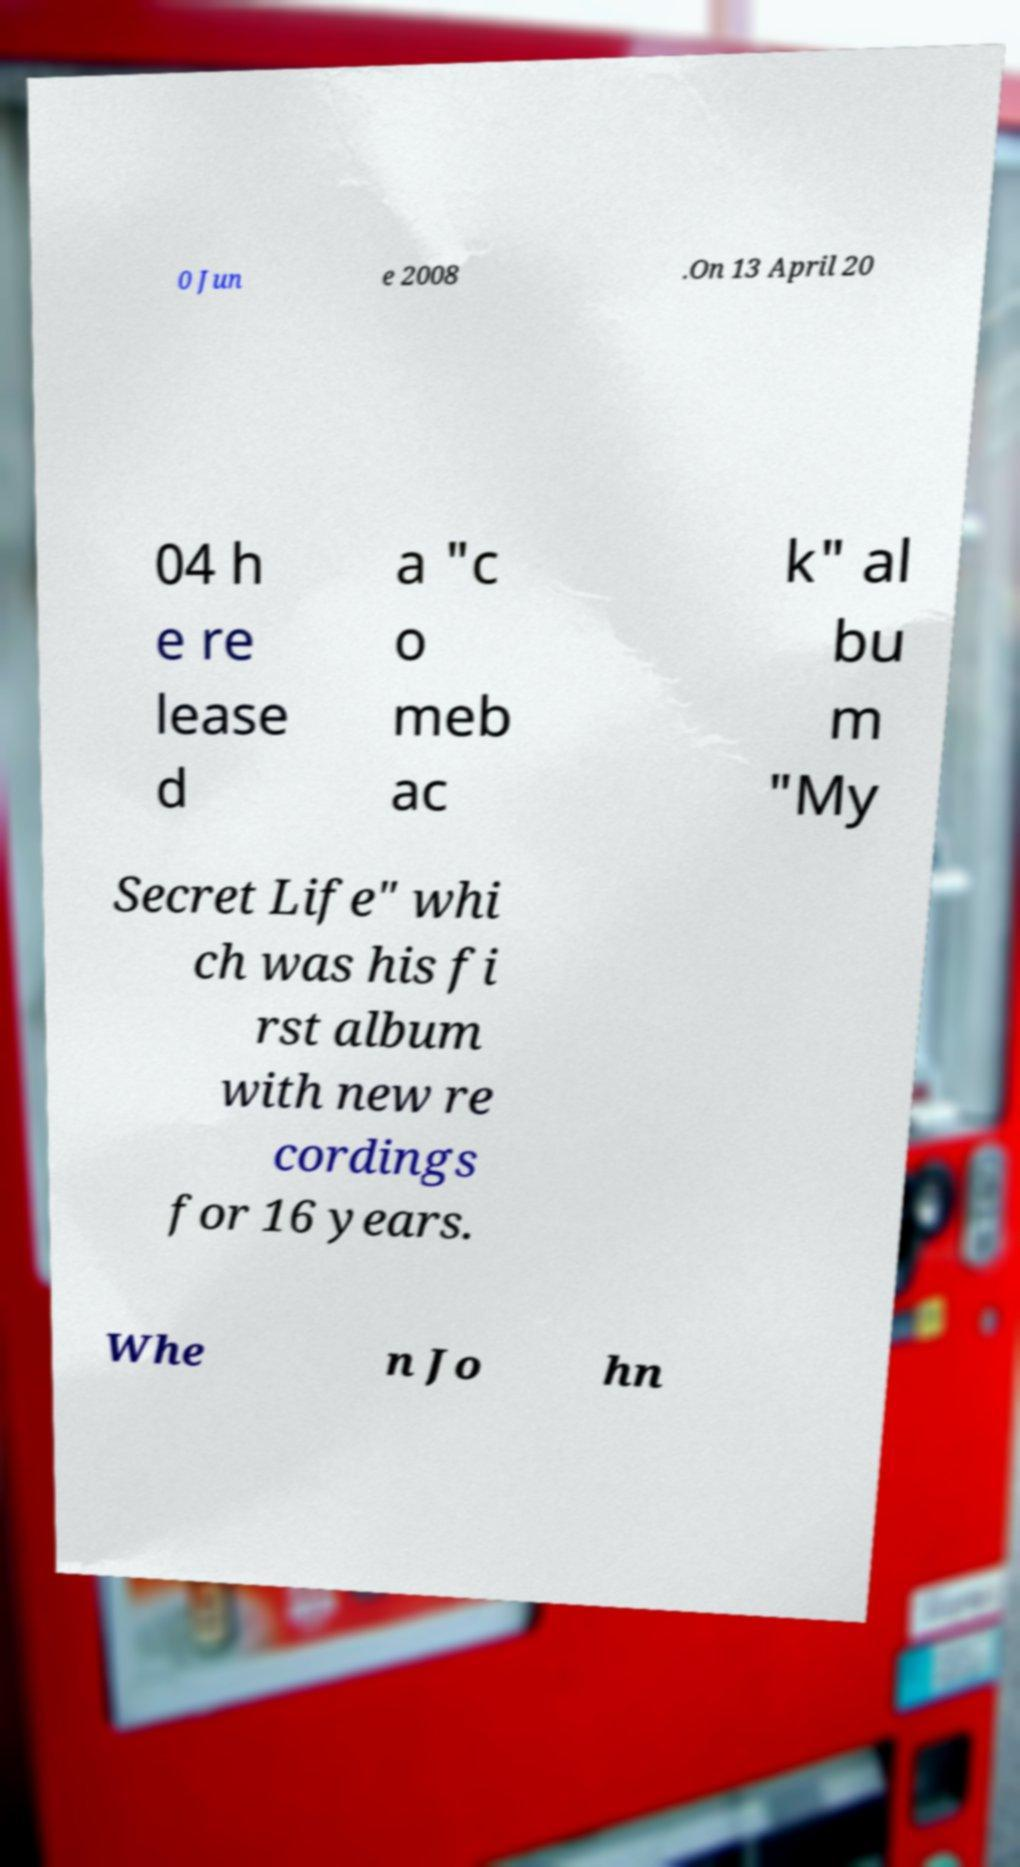Could you assist in decoding the text presented in this image and type it out clearly? 0 Jun e 2008 .On 13 April 20 04 h e re lease d a "c o meb ac k" al bu m "My Secret Life" whi ch was his fi rst album with new re cordings for 16 years. Whe n Jo hn 